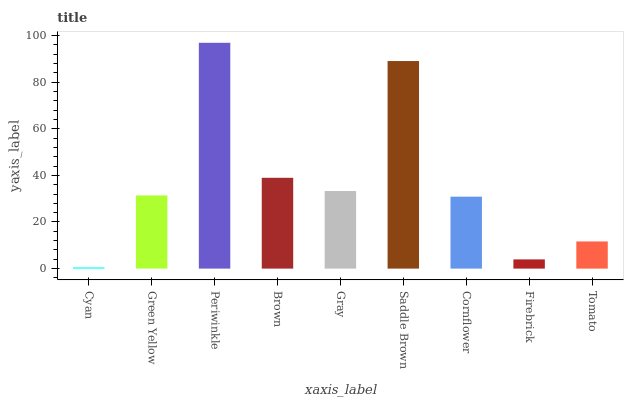Is Green Yellow the minimum?
Answer yes or no. No. Is Green Yellow the maximum?
Answer yes or no. No. Is Green Yellow greater than Cyan?
Answer yes or no. Yes. Is Cyan less than Green Yellow?
Answer yes or no. Yes. Is Cyan greater than Green Yellow?
Answer yes or no. No. Is Green Yellow less than Cyan?
Answer yes or no. No. Is Green Yellow the high median?
Answer yes or no. Yes. Is Green Yellow the low median?
Answer yes or no. Yes. Is Cyan the high median?
Answer yes or no. No. Is Saddle Brown the low median?
Answer yes or no. No. 